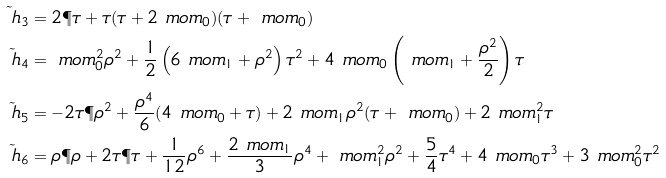<formula> <loc_0><loc_0><loc_500><loc_500>\tilde { \ h } _ { 3 } & = 2 \P { \tau } + \tau ( \tau + 2 \ m o m _ { 0 } ) ( \tau + \ m o m _ { 0 } ) \\ \tilde { \ h } _ { 4 } & = \ m o m _ { 0 } ^ { 2 } \rho ^ { 2 } + \frac { 1 } { 2 } \left ( 6 \ m o m _ { 1 } + \rho ^ { 2 } \right ) \tau ^ { 2 } + 4 \ m o m _ { 0 } \left ( \ m o m _ { 1 } + \frac { \rho ^ { 2 } } { 2 } \right ) \tau \\ \tilde { \ h } _ { 5 } & = - 2 \tau \P { \rho } ^ { 2 } + \frac { \rho ^ { 4 } } { 6 } ( 4 \ m o m _ { 0 } + \tau ) + 2 \ m o m _ { 1 } \rho ^ { 2 } ( \tau + \ m o m _ { 0 } ) + 2 \ m o m _ { 1 } ^ { 2 } \tau \\ \tilde { \ h } _ { 6 } & = \rho \P { \rho } + 2 \tau \P { \tau } + \frac { 1 } { 1 2 } \rho ^ { 6 } + \frac { 2 \ m o m _ { 1 } } { 3 } \rho ^ { 4 } + \ m o m _ { 1 } ^ { 2 } \rho ^ { 2 } + \frac { 5 } { 4 } \tau ^ { 4 } + 4 \ m o m _ { 0 } \tau ^ { 3 } + 3 \ m o m _ { 0 } ^ { 2 } \tau ^ { 2 }</formula> 